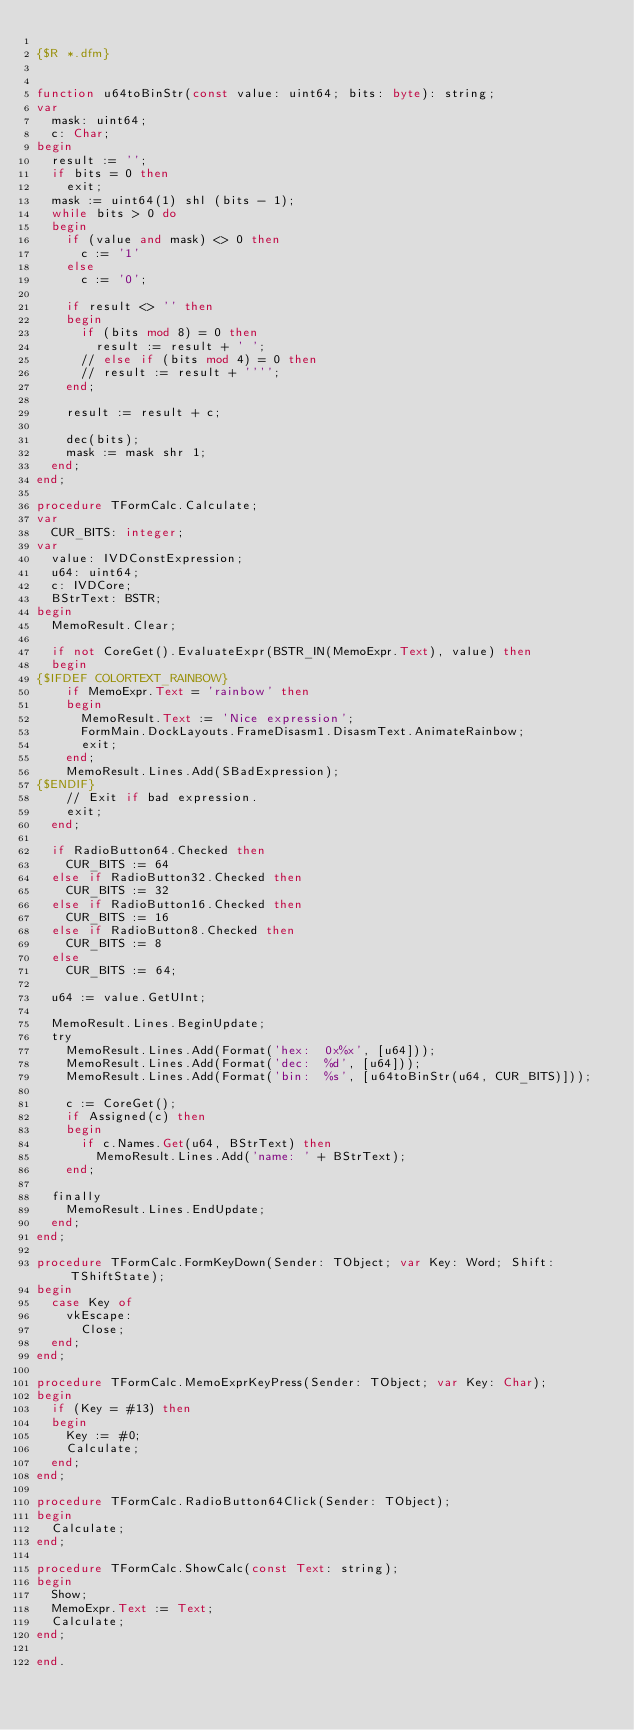<code> <loc_0><loc_0><loc_500><loc_500><_Pascal_>
{$R *.dfm}


function u64toBinStr(const value: uint64; bits: byte): string;
var
  mask: uint64;
  c: Char;
begin
  result := '';
  if bits = 0 then
    exit;
  mask := uint64(1) shl (bits - 1);
  while bits > 0 do
  begin
    if (value and mask) <> 0 then
      c := '1'
    else
      c := '0';

    if result <> '' then
    begin
      if (bits mod 8) = 0 then
        result := result + ' ';
      // else if (bits mod 4) = 0 then
      // result := result + '''';
    end;

    result := result + c;

    dec(bits);
    mask := mask shr 1;
  end;
end;

procedure TFormCalc.Calculate;
var
  CUR_BITS: integer;
var
  value: IVDConstExpression;
  u64: uint64;
  c: IVDCore;
  BStrText: BSTR;
begin
  MemoResult.Clear;

  if not CoreGet().EvaluateExpr(BSTR_IN(MemoExpr.Text), value) then
  begin
{$IFDEF COLORTEXT_RAINBOW}
    if MemoExpr.Text = 'rainbow' then
    begin
      MemoResult.Text := 'Nice expression';
      FormMain.DockLayouts.FrameDisasm1.DisasmText.AnimateRainbow;
      exit;
    end;
    MemoResult.Lines.Add(SBadExpression);
{$ENDIF}
    // Exit if bad expression.
    exit;
  end;

  if RadioButton64.Checked then
    CUR_BITS := 64
  else if RadioButton32.Checked then
    CUR_BITS := 32
  else if RadioButton16.Checked then
    CUR_BITS := 16
  else if RadioButton8.Checked then
    CUR_BITS := 8
  else
    CUR_BITS := 64;

  u64 := value.GetUInt;

  MemoResult.Lines.BeginUpdate;
  try
    MemoResult.Lines.Add(Format('hex:  0x%x', [u64]));
    MemoResult.Lines.Add(Format('dec:  %d', [u64]));
    MemoResult.Lines.Add(Format('bin:  %s', [u64toBinStr(u64, CUR_BITS)]));

    c := CoreGet();
    if Assigned(c) then
    begin
      if c.Names.Get(u64, BStrText) then
        MemoResult.Lines.Add('name: ' + BStrText);
    end;

  finally
    MemoResult.Lines.EndUpdate;
  end;
end;

procedure TFormCalc.FormKeyDown(Sender: TObject; var Key: Word; Shift: TShiftState);
begin
  case Key of
    vkEscape:
      Close;
  end;
end;

procedure TFormCalc.MemoExprKeyPress(Sender: TObject; var Key: Char);
begin
  if (Key = #13) then
  begin
    Key := #0;
    Calculate;
  end;
end;

procedure TFormCalc.RadioButton64Click(Sender: TObject);
begin
  Calculate;
end;

procedure TFormCalc.ShowCalc(const Text: string);
begin
  Show;
  MemoExpr.Text := Text;
  Calculate;
end;

end.
</code> 